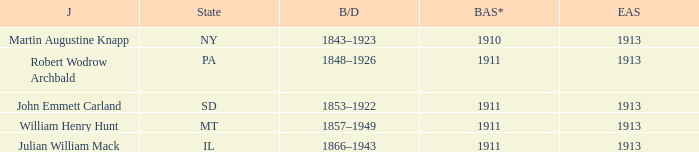Who was the judge for the state SD? John Emmett Carland. 